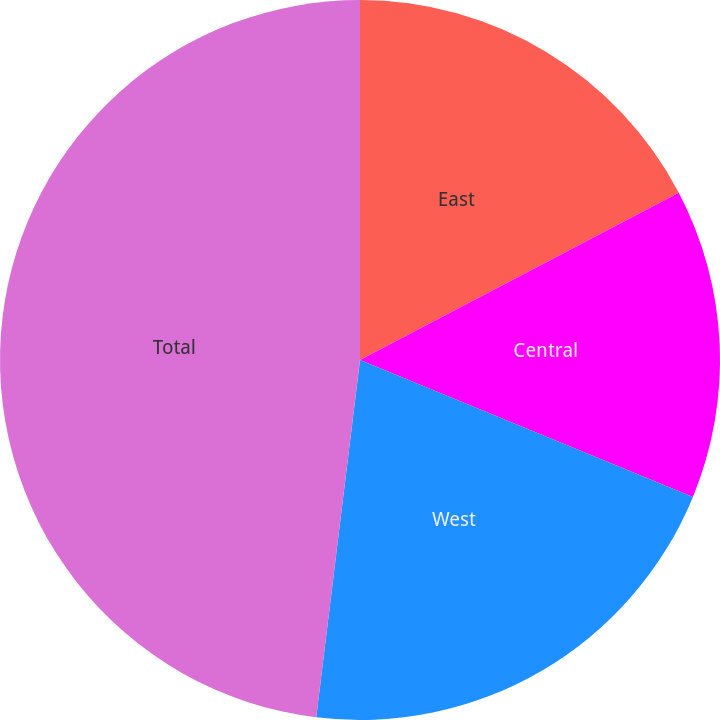<chart> <loc_0><loc_0><loc_500><loc_500><pie_chart><fcel>East<fcel>Central<fcel>West<fcel>Total<nl><fcel>17.31%<fcel>13.9%<fcel>20.73%<fcel>48.06%<nl></chart> 